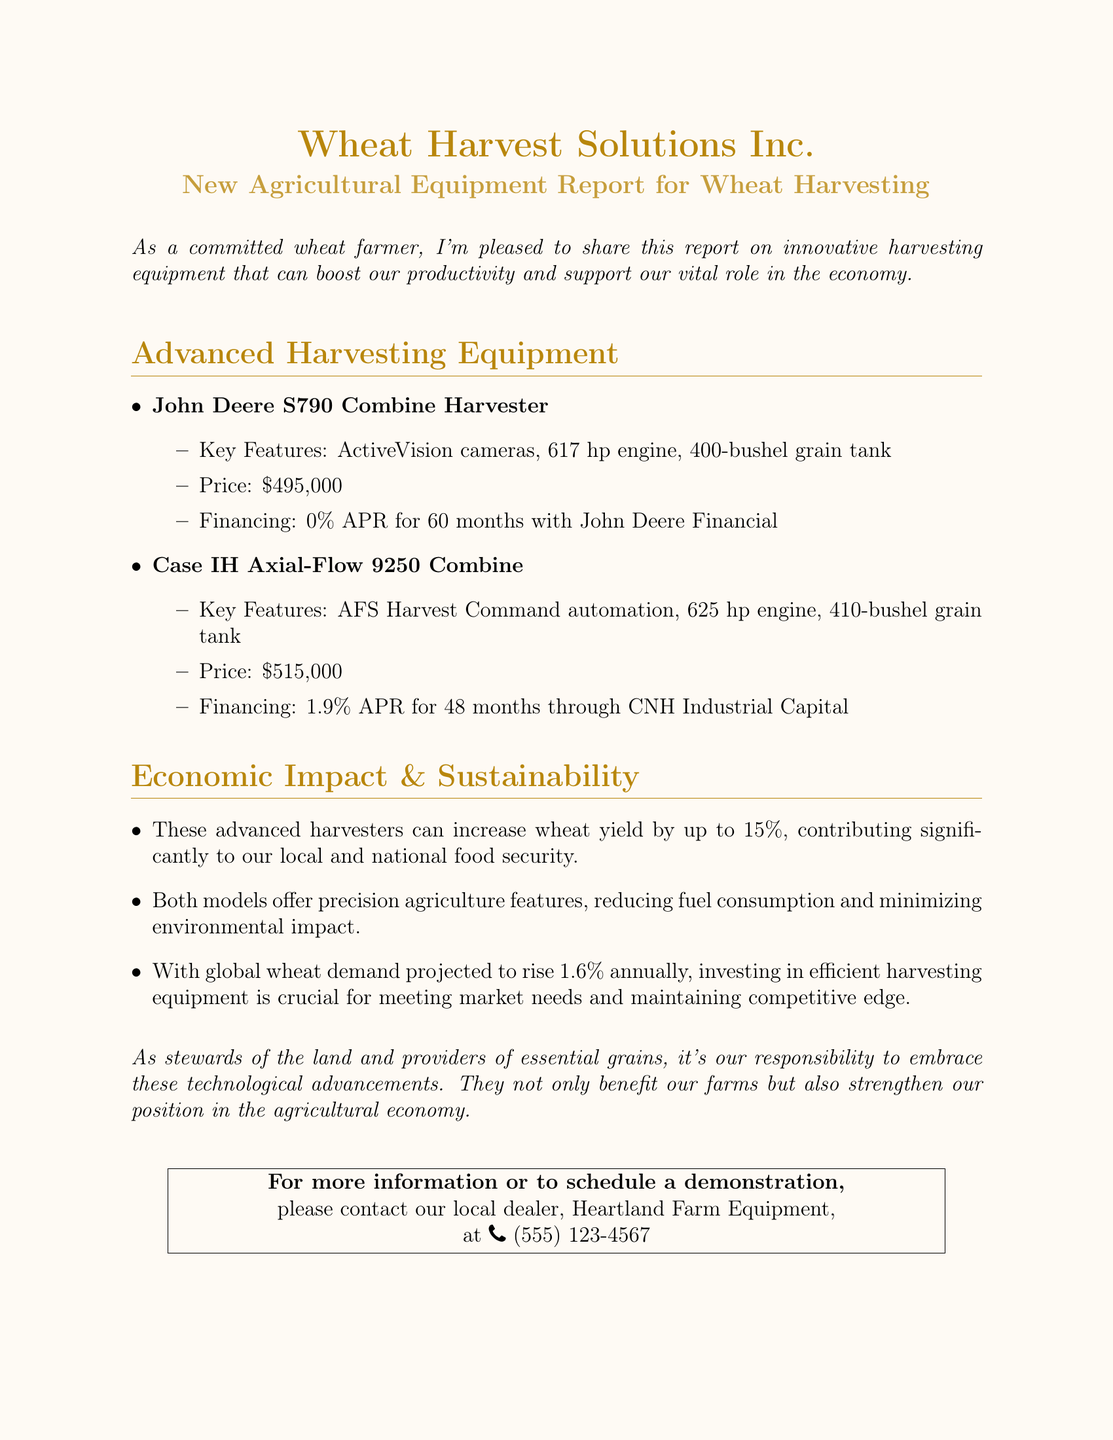What is the price of the John Deere S790 Combine Harvester? The price for the John Deere S790 Combine Harvester is specified in the document.
Answer: $495,000 What is the financing option for the Case IH Axial-Flow 9250 Combine? The document states the financing option available for the Case IH Axial-Flow 9250 Combine.
Answer: 1.9% APR for 48 months How much can advanced harvesters increase wheat yield? The document mentions a specific percentage for increased wheat yield due to advanced harvesters.
Answer: Up to 15% Who is the local dealer for more information? The document provides the name of the local dealer for contacting and scheduling a demonstration.
Answer: Heartland Farm Equipment What is the horsepower of the Case IH Axial-Flow 9250 Combine? The horsepower of the Case IH Axial-Flow 9250 Combine is noted in the specifications section of the document.
Answer: 625 hp What is the projected annual rise in global wheat demand? The document includes a statistic regarding the projected rise in global wheat demand.
Answer: 1.6% annually 